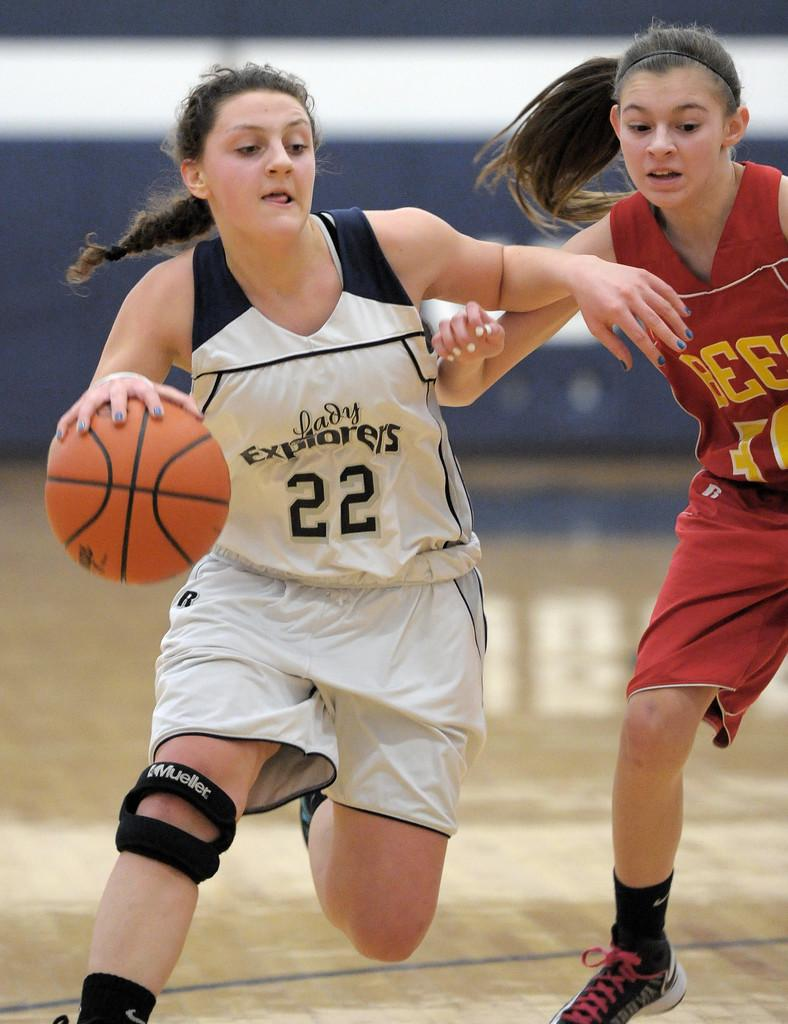How many people are in the image? There are two persons in the image. What are the two persons doing in the image? The two persons are playing a game. Can you describe the clothing of the person in front? The person in front is wearing a white and black dress. What object is involved in the game being played? There is a ball in the image, and it is brown in color. How would you describe the background of the image? The background of the image is blurred. How many babies are crawling on the floor in the image? There are no babies present in the image; it features two persons playing a game with a ball. What type of test is being conducted in the image? There is no test being conducted in the image; it shows two people playing a game with a ball. 